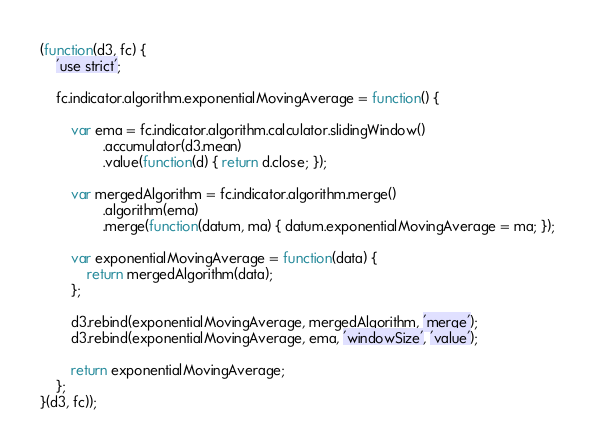Convert code to text. <code><loc_0><loc_0><loc_500><loc_500><_JavaScript_>(function(d3, fc) {
    'use strict';

    fc.indicator.algorithm.exponentialMovingAverage = function() {

        var ema = fc.indicator.algorithm.calculator.slidingWindow()
                .accumulator(d3.mean)
                .value(function(d) { return d.close; });

        var mergedAlgorithm = fc.indicator.algorithm.merge()
                .algorithm(ema)
                .merge(function(datum, ma) { datum.exponentialMovingAverage = ma; });

        var exponentialMovingAverage = function(data) {
            return mergedAlgorithm(data);
        };

        d3.rebind(exponentialMovingAverage, mergedAlgorithm, 'merge');
        d3.rebind(exponentialMovingAverage, ema, 'windowSize', 'value');

        return exponentialMovingAverage;
    };
}(d3, fc));
</code> 